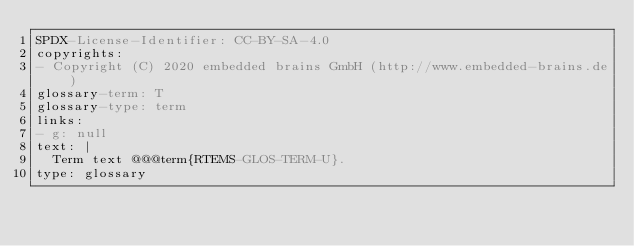Convert code to text. <code><loc_0><loc_0><loc_500><loc_500><_YAML_>SPDX-License-Identifier: CC-BY-SA-4.0
copyrights:
- Copyright (C) 2020 embedded brains GmbH (http://www.embedded-brains.de)
glossary-term: T
glossary-type: term
links:
- g: null
text: |
  Term text @@@term{RTEMS-GLOS-TERM-U}.
type: glossary
</code> 